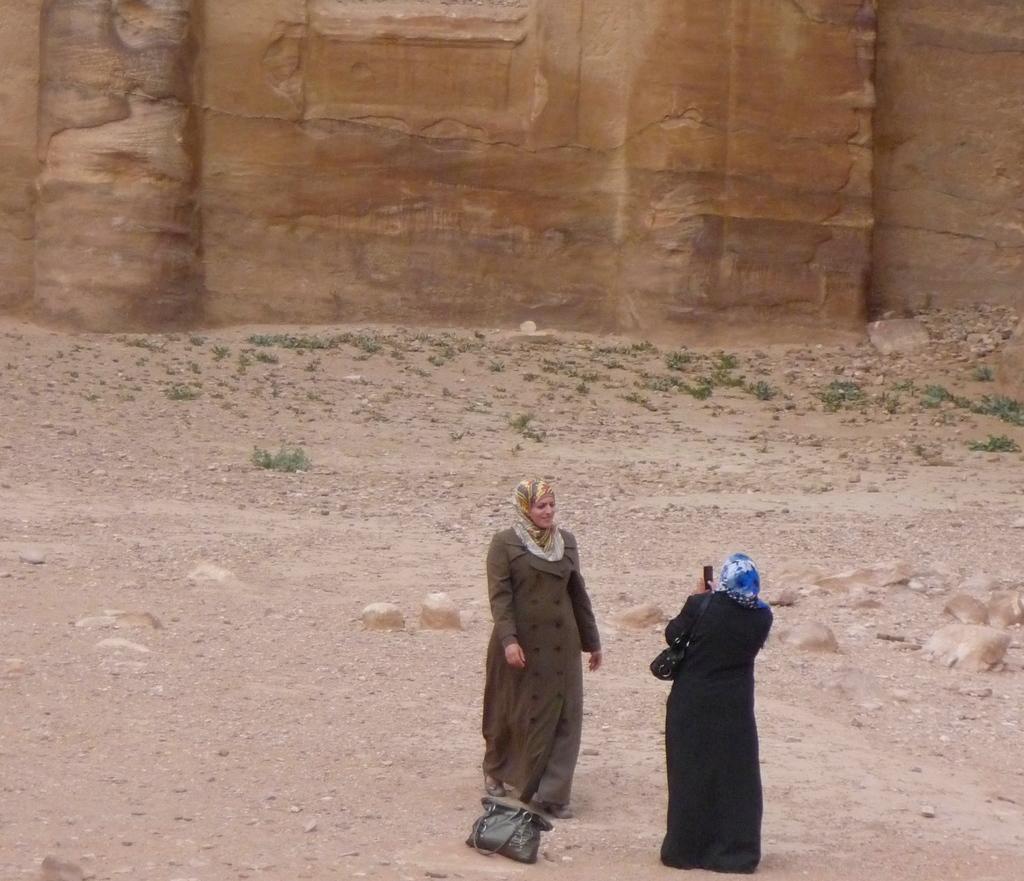Could you give a brief overview of what you see in this image? There is a woman in black color dress, holding a mobile and capturing a person who is walking on the ground near a handbag. In the background, there are rocks, small stones and grass on the ground and there is a wall. 